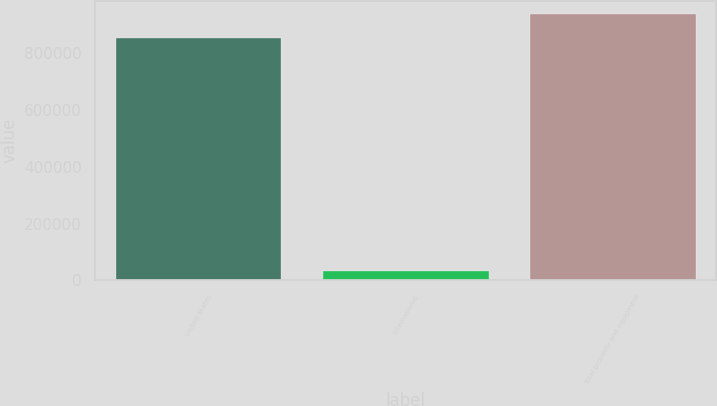<chart> <loc_0><loc_0><loc_500><loc_500><bar_chart><fcel>United States<fcel>International<fcel>Total property and equipment<nl><fcel>853731<fcel>31347<fcel>939104<nl></chart> 